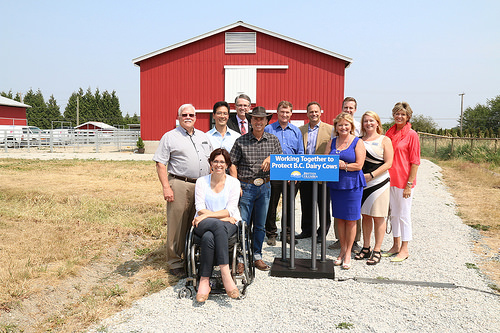<image>
Is there a woman behind the woman? Yes. From this viewpoint, the woman is positioned behind the woman, with the woman partially or fully occluding the woman. Where is the fence in relation to the man? Is it behind the man? Yes. From this viewpoint, the fence is positioned behind the man, with the man partially or fully occluding the fence. 